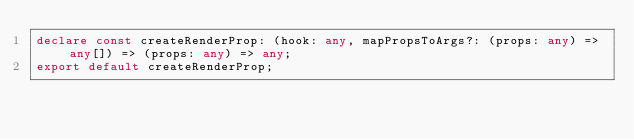Convert code to text. <code><loc_0><loc_0><loc_500><loc_500><_TypeScript_>declare const createRenderProp: (hook: any, mapPropsToArgs?: (props: any) => any[]) => (props: any) => any;
export default createRenderProp;
</code> 